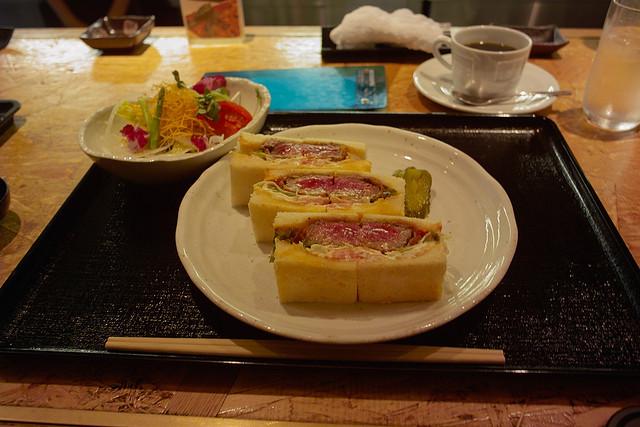Is the coffee cup empty?
Quick response, please. No. What is this person eating?
Quick response, please. Sandwich. Is this person having a meal alone?
Short answer required. Yes. 